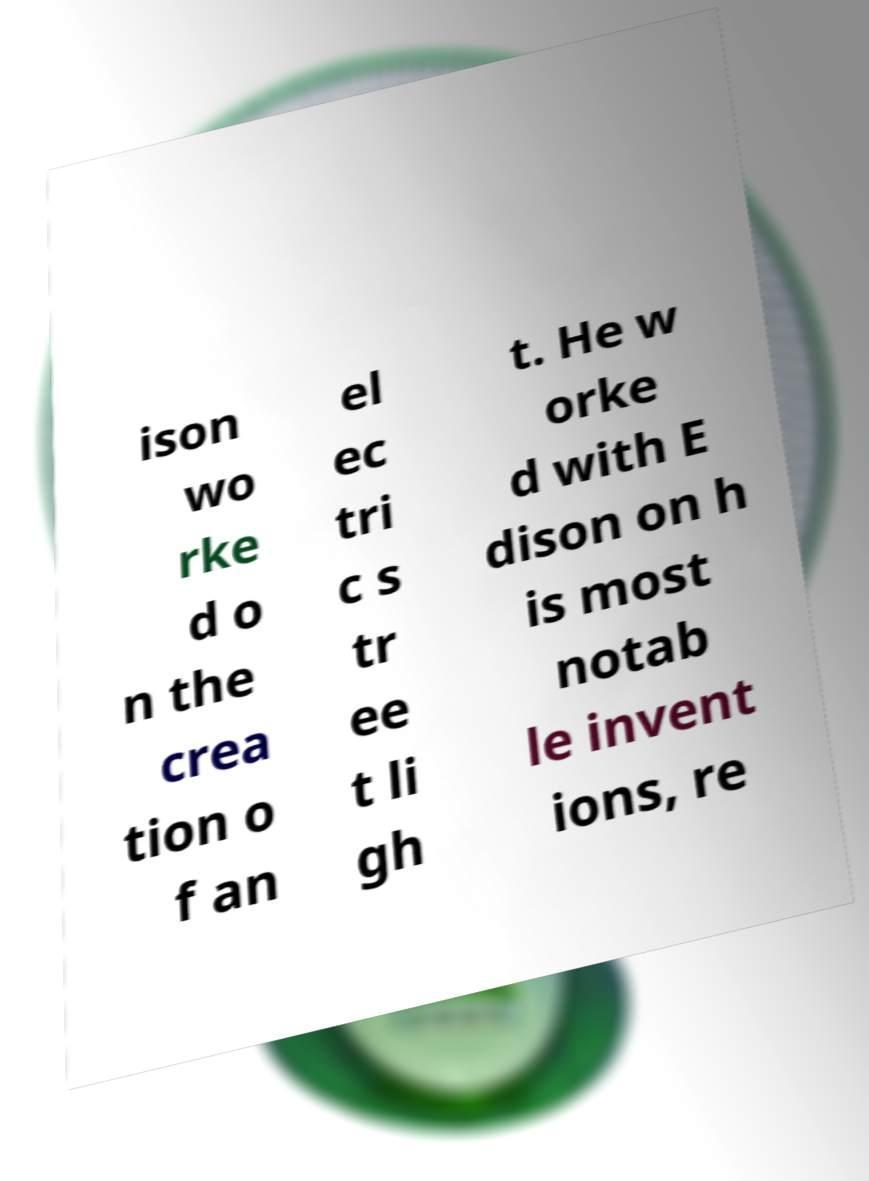For documentation purposes, I need the text within this image transcribed. Could you provide that? ison wo rke d o n the crea tion o f an el ec tri c s tr ee t li gh t. He w orke d with E dison on h is most notab le invent ions, re 